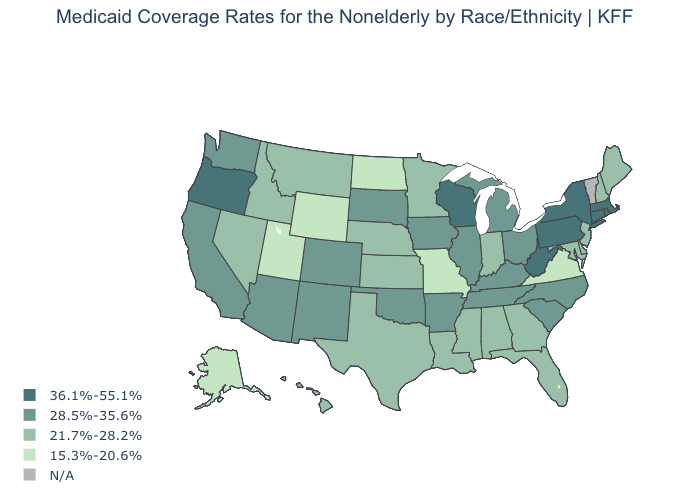Name the states that have a value in the range 36.1%-55.1%?
Concise answer only. Connecticut, Massachusetts, New York, Oregon, Pennsylvania, Rhode Island, West Virginia, Wisconsin. What is the value of Indiana?
Short answer required. 21.7%-28.2%. Name the states that have a value in the range N/A?
Concise answer only. Vermont. Which states have the lowest value in the USA?
Give a very brief answer. Alaska, Missouri, North Dakota, Utah, Virginia, Wyoming. What is the value of Wyoming?
Give a very brief answer. 15.3%-20.6%. What is the highest value in states that border Massachusetts?
Write a very short answer. 36.1%-55.1%. What is the value of Rhode Island?
Give a very brief answer. 36.1%-55.1%. What is the highest value in states that border Vermont?
Give a very brief answer. 36.1%-55.1%. Among the states that border Iowa , which have the lowest value?
Quick response, please. Missouri. Does the map have missing data?
Concise answer only. Yes. Is the legend a continuous bar?
Give a very brief answer. No. What is the value of West Virginia?
Keep it brief. 36.1%-55.1%. What is the highest value in states that border Kansas?
Concise answer only. 28.5%-35.6%. Does West Virginia have the highest value in the South?
Short answer required. Yes. 